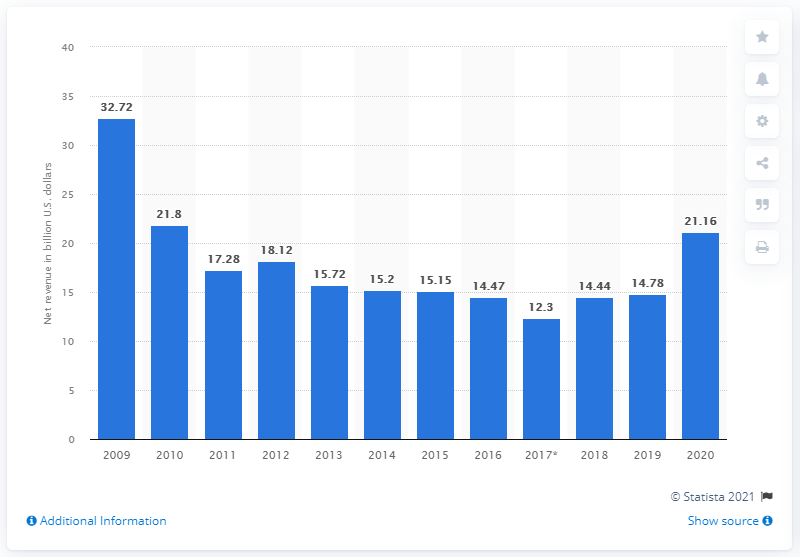List a handful of essential elements in this visual. In 2020, the net revenue from institutional client services at Goldman Sachs was 21.16 billion dollars. 